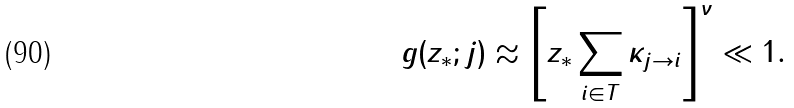Convert formula to latex. <formula><loc_0><loc_0><loc_500><loc_500>g ( z _ { * } ; j ) \approx \left [ z _ { * } \sum _ { i \in T } \kappa _ { j \rightarrow i } \right ] ^ { \nu } \ll 1 .</formula> 